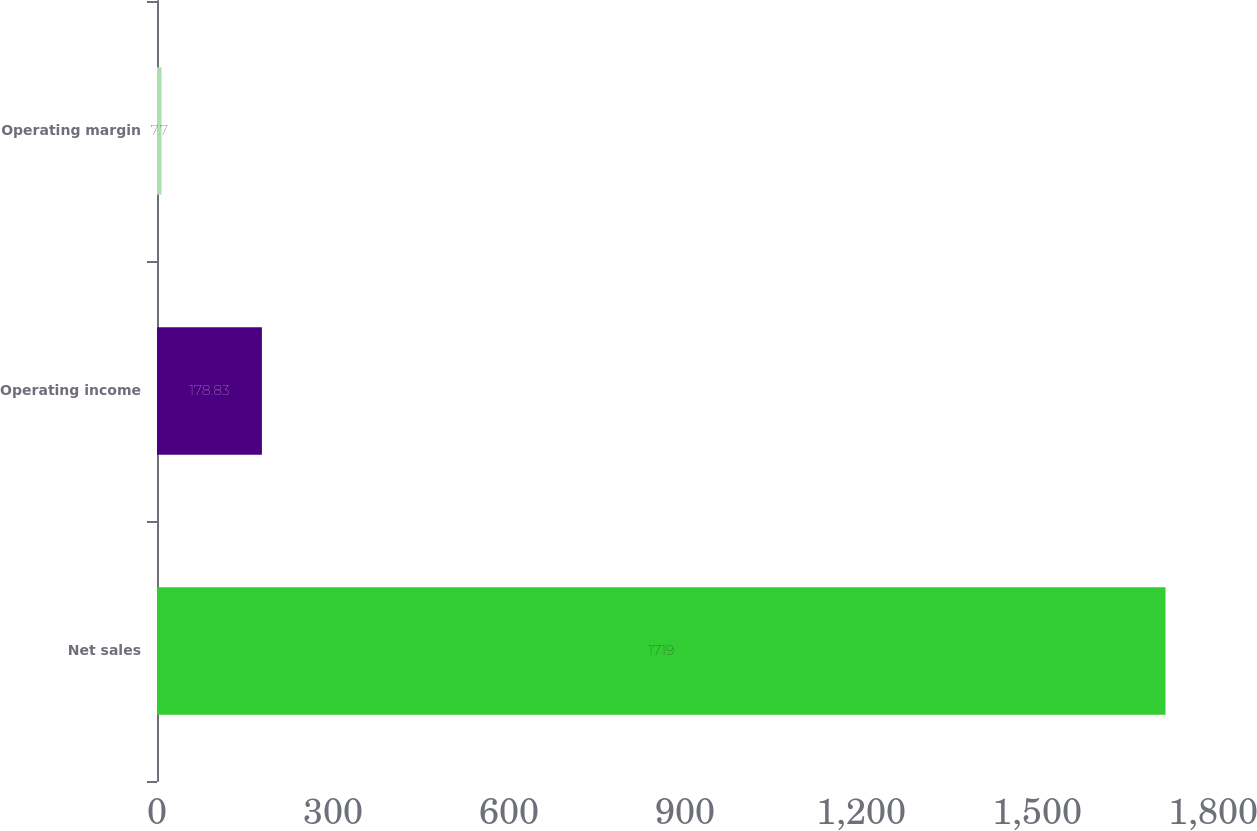<chart> <loc_0><loc_0><loc_500><loc_500><bar_chart><fcel>Net sales<fcel>Operating income<fcel>Operating margin<nl><fcel>1719<fcel>178.83<fcel>7.7<nl></chart> 